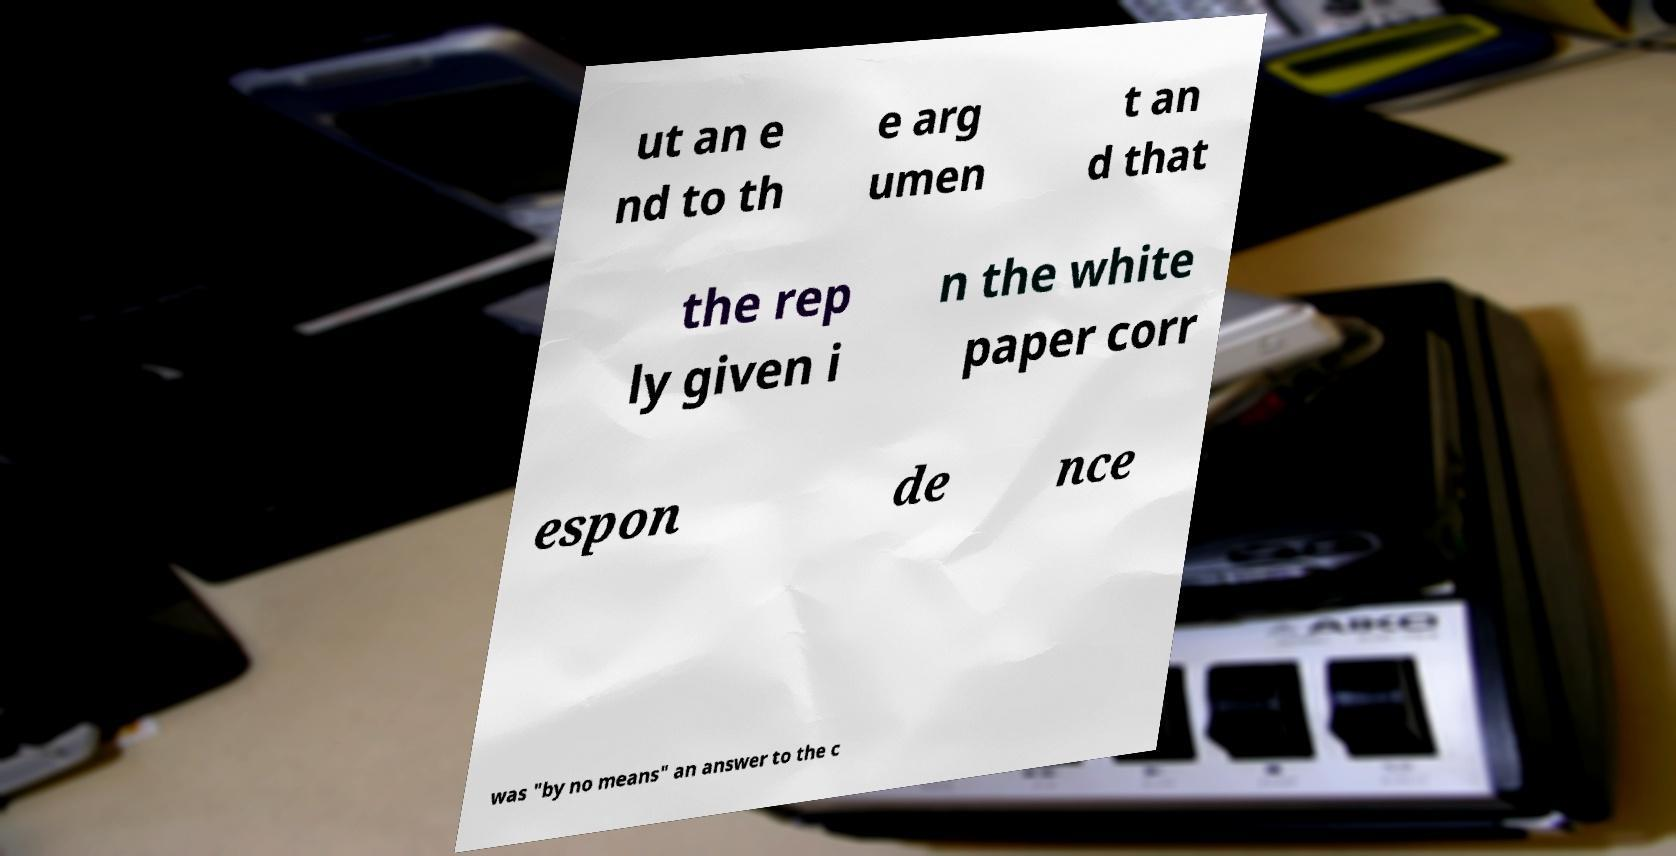I need the written content from this picture converted into text. Can you do that? ut an e nd to th e arg umen t an d that the rep ly given i n the white paper corr espon de nce was "by no means" an answer to the c 